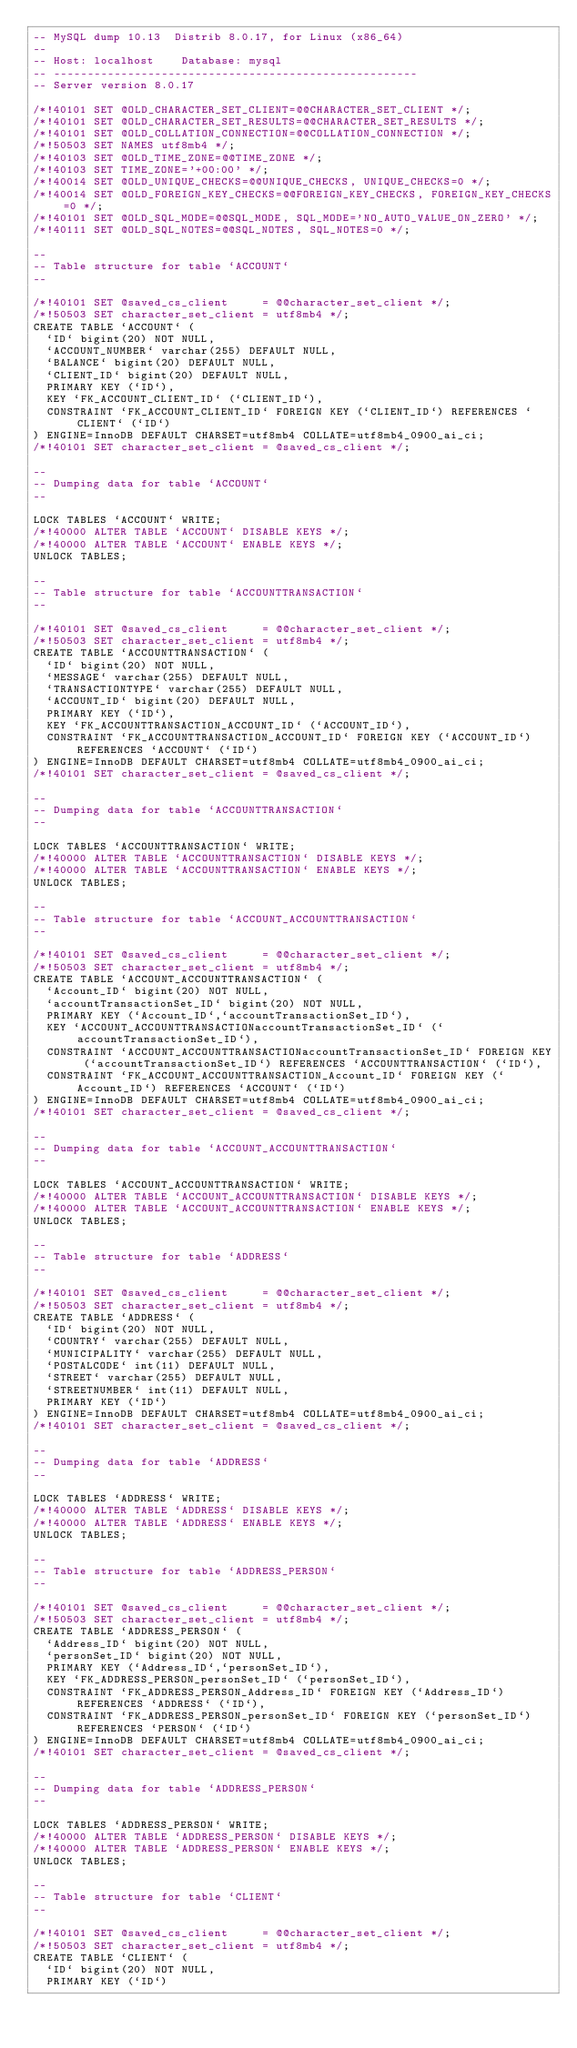<code> <loc_0><loc_0><loc_500><loc_500><_SQL_>-- MySQL dump 10.13  Distrib 8.0.17, for Linux (x86_64)
--
-- Host: localhost    Database: mysql
-- ------------------------------------------------------
-- Server version	8.0.17

/*!40101 SET @OLD_CHARACTER_SET_CLIENT=@@CHARACTER_SET_CLIENT */;
/*!40101 SET @OLD_CHARACTER_SET_RESULTS=@@CHARACTER_SET_RESULTS */;
/*!40101 SET @OLD_COLLATION_CONNECTION=@@COLLATION_CONNECTION */;
/*!50503 SET NAMES utf8mb4 */;
/*!40103 SET @OLD_TIME_ZONE=@@TIME_ZONE */;
/*!40103 SET TIME_ZONE='+00:00' */;
/*!40014 SET @OLD_UNIQUE_CHECKS=@@UNIQUE_CHECKS, UNIQUE_CHECKS=0 */;
/*!40014 SET @OLD_FOREIGN_KEY_CHECKS=@@FOREIGN_KEY_CHECKS, FOREIGN_KEY_CHECKS=0 */;
/*!40101 SET @OLD_SQL_MODE=@@SQL_MODE, SQL_MODE='NO_AUTO_VALUE_ON_ZERO' */;
/*!40111 SET @OLD_SQL_NOTES=@@SQL_NOTES, SQL_NOTES=0 */;

--
-- Table structure for table `ACCOUNT`
--

/*!40101 SET @saved_cs_client     = @@character_set_client */;
/*!50503 SET character_set_client = utf8mb4 */;
CREATE TABLE `ACCOUNT` (
  `ID` bigint(20) NOT NULL,
  `ACCOUNT_NUMBER` varchar(255) DEFAULT NULL,
  `BALANCE` bigint(20) DEFAULT NULL,
  `CLIENT_ID` bigint(20) DEFAULT NULL,
  PRIMARY KEY (`ID`),
  KEY `FK_ACCOUNT_CLIENT_ID` (`CLIENT_ID`),
  CONSTRAINT `FK_ACCOUNT_CLIENT_ID` FOREIGN KEY (`CLIENT_ID`) REFERENCES `CLIENT` (`ID`)
) ENGINE=InnoDB DEFAULT CHARSET=utf8mb4 COLLATE=utf8mb4_0900_ai_ci;
/*!40101 SET character_set_client = @saved_cs_client */;

--
-- Dumping data for table `ACCOUNT`
--

LOCK TABLES `ACCOUNT` WRITE;
/*!40000 ALTER TABLE `ACCOUNT` DISABLE KEYS */;
/*!40000 ALTER TABLE `ACCOUNT` ENABLE KEYS */;
UNLOCK TABLES;

--
-- Table structure for table `ACCOUNTTRANSACTION`
--

/*!40101 SET @saved_cs_client     = @@character_set_client */;
/*!50503 SET character_set_client = utf8mb4 */;
CREATE TABLE `ACCOUNTTRANSACTION` (
  `ID` bigint(20) NOT NULL,
  `MESSAGE` varchar(255) DEFAULT NULL,
  `TRANSACTIONTYPE` varchar(255) DEFAULT NULL,
  `ACCOUNT_ID` bigint(20) DEFAULT NULL,
  PRIMARY KEY (`ID`),
  KEY `FK_ACCOUNTTRANSACTION_ACCOUNT_ID` (`ACCOUNT_ID`),
  CONSTRAINT `FK_ACCOUNTTRANSACTION_ACCOUNT_ID` FOREIGN KEY (`ACCOUNT_ID`) REFERENCES `ACCOUNT` (`ID`)
) ENGINE=InnoDB DEFAULT CHARSET=utf8mb4 COLLATE=utf8mb4_0900_ai_ci;
/*!40101 SET character_set_client = @saved_cs_client */;

--
-- Dumping data for table `ACCOUNTTRANSACTION`
--

LOCK TABLES `ACCOUNTTRANSACTION` WRITE;
/*!40000 ALTER TABLE `ACCOUNTTRANSACTION` DISABLE KEYS */;
/*!40000 ALTER TABLE `ACCOUNTTRANSACTION` ENABLE KEYS */;
UNLOCK TABLES;

--
-- Table structure for table `ACCOUNT_ACCOUNTTRANSACTION`
--

/*!40101 SET @saved_cs_client     = @@character_set_client */;
/*!50503 SET character_set_client = utf8mb4 */;
CREATE TABLE `ACCOUNT_ACCOUNTTRANSACTION` (
  `Account_ID` bigint(20) NOT NULL,
  `accountTransactionSet_ID` bigint(20) NOT NULL,
  PRIMARY KEY (`Account_ID`,`accountTransactionSet_ID`),
  KEY `ACCOUNT_ACCOUNTTRANSACTIONaccountTransactionSet_ID` (`accountTransactionSet_ID`),
  CONSTRAINT `ACCOUNT_ACCOUNTTRANSACTIONaccountTransactionSet_ID` FOREIGN KEY (`accountTransactionSet_ID`) REFERENCES `ACCOUNTTRANSACTION` (`ID`),
  CONSTRAINT `FK_ACCOUNT_ACCOUNTTRANSACTION_Account_ID` FOREIGN KEY (`Account_ID`) REFERENCES `ACCOUNT` (`ID`)
) ENGINE=InnoDB DEFAULT CHARSET=utf8mb4 COLLATE=utf8mb4_0900_ai_ci;
/*!40101 SET character_set_client = @saved_cs_client */;

--
-- Dumping data for table `ACCOUNT_ACCOUNTTRANSACTION`
--

LOCK TABLES `ACCOUNT_ACCOUNTTRANSACTION` WRITE;
/*!40000 ALTER TABLE `ACCOUNT_ACCOUNTTRANSACTION` DISABLE KEYS */;
/*!40000 ALTER TABLE `ACCOUNT_ACCOUNTTRANSACTION` ENABLE KEYS */;
UNLOCK TABLES;

--
-- Table structure for table `ADDRESS`
--

/*!40101 SET @saved_cs_client     = @@character_set_client */;
/*!50503 SET character_set_client = utf8mb4 */;
CREATE TABLE `ADDRESS` (
  `ID` bigint(20) NOT NULL,
  `COUNTRY` varchar(255) DEFAULT NULL,
  `MUNICIPALITY` varchar(255) DEFAULT NULL,
  `POSTALCODE` int(11) DEFAULT NULL,
  `STREET` varchar(255) DEFAULT NULL,
  `STREETNUMBER` int(11) DEFAULT NULL,
  PRIMARY KEY (`ID`)
) ENGINE=InnoDB DEFAULT CHARSET=utf8mb4 COLLATE=utf8mb4_0900_ai_ci;
/*!40101 SET character_set_client = @saved_cs_client */;

--
-- Dumping data for table `ADDRESS`
--

LOCK TABLES `ADDRESS` WRITE;
/*!40000 ALTER TABLE `ADDRESS` DISABLE KEYS */;
/*!40000 ALTER TABLE `ADDRESS` ENABLE KEYS */;
UNLOCK TABLES;

--
-- Table structure for table `ADDRESS_PERSON`
--

/*!40101 SET @saved_cs_client     = @@character_set_client */;
/*!50503 SET character_set_client = utf8mb4 */;
CREATE TABLE `ADDRESS_PERSON` (
  `Address_ID` bigint(20) NOT NULL,
  `personSet_ID` bigint(20) NOT NULL,
  PRIMARY KEY (`Address_ID`,`personSet_ID`),
  KEY `FK_ADDRESS_PERSON_personSet_ID` (`personSet_ID`),
  CONSTRAINT `FK_ADDRESS_PERSON_Address_ID` FOREIGN KEY (`Address_ID`) REFERENCES `ADDRESS` (`ID`),
  CONSTRAINT `FK_ADDRESS_PERSON_personSet_ID` FOREIGN KEY (`personSet_ID`) REFERENCES `PERSON` (`ID`)
) ENGINE=InnoDB DEFAULT CHARSET=utf8mb4 COLLATE=utf8mb4_0900_ai_ci;
/*!40101 SET character_set_client = @saved_cs_client */;

--
-- Dumping data for table `ADDRESS_PERSON`
--

LOCK TABLES `ADDRESS_PERSON` WRITE;
/*!40000 ALTER TABLE `ADDRESS_PERSON` DISABLE KEYS */;
/*!40000 ALTER TABLE `ADDRESS_PERSON` ENABLE KEYS */;
UNLOCK TABLES;

--
-- Table structure for table `CLIENT`
--

/*!40101 SET @saved_cs_client     = @@character_set_client */;
/*!50503 SET character_set_client = utf8mb4 */;
CREATE TABLE `CLIENT` (
  `ID` bigint(20) NOT NULL,
  PRIMARY KEY (`ID`)</code> 